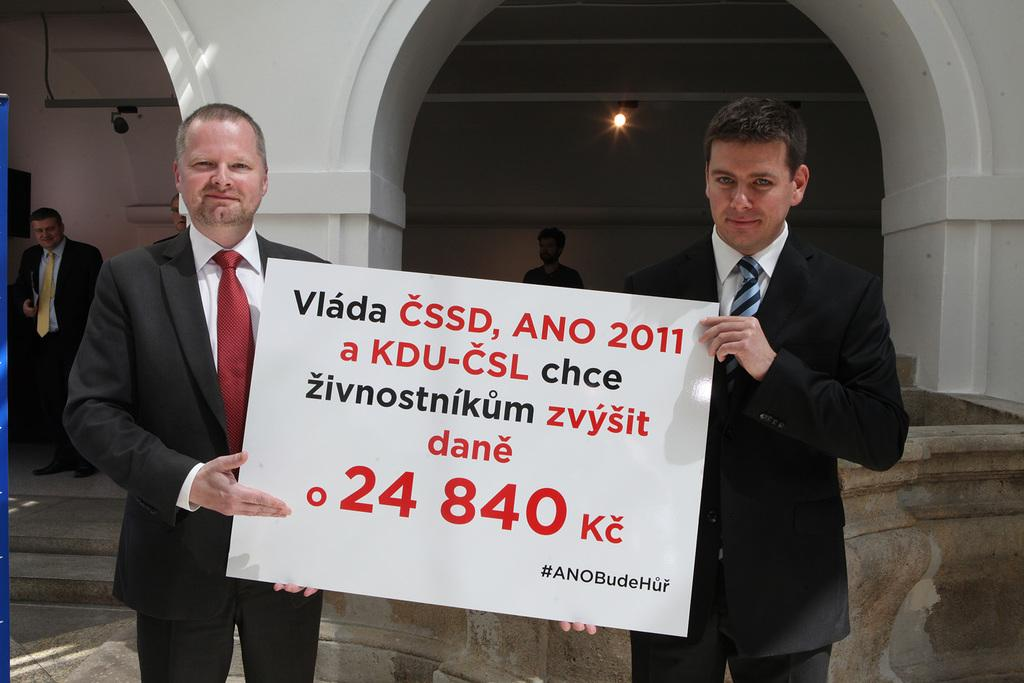How many people are visible in the image? There are two people standing in the image. What are the two people holding? The two people are holding a board. What can be seen on the board? There is text on the board. Can you describe the background of the image? In the background of the image, there are two people, pillars, a wall, lights, and objects. What type of juice is being squeezed by the potato in the image? There is no juice or potato present in the image. What is the relation between the two people holding the board and the two people in the background? The provided facts do not give any information about the relation between the people in the image. 